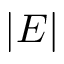Convert formula to latex. <formula><loc_0><loc_0><loc_500><loc_500>| E |</formula> 